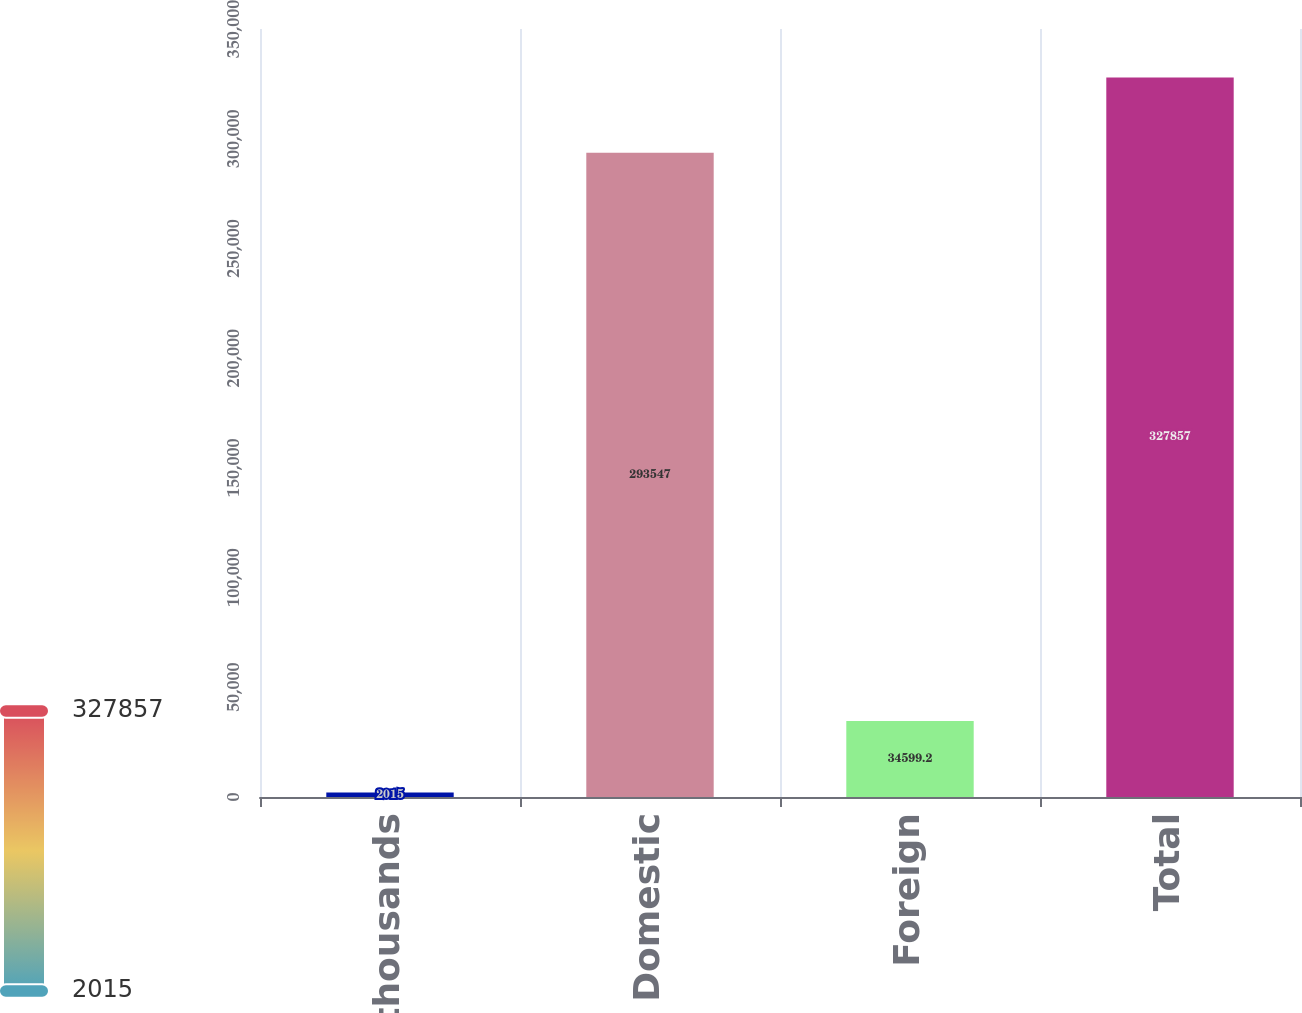Convert chart to OTSL. <chart><loc_0><loc_0><loc_500><loc_500><bar_chart><fcel>in thousands<fcel>Domestic<fcel>Foreign<fcel>Total<nl><fcel>2015<fcel>293547<fcel>34599.2<fcel>327857<nl></chart> 